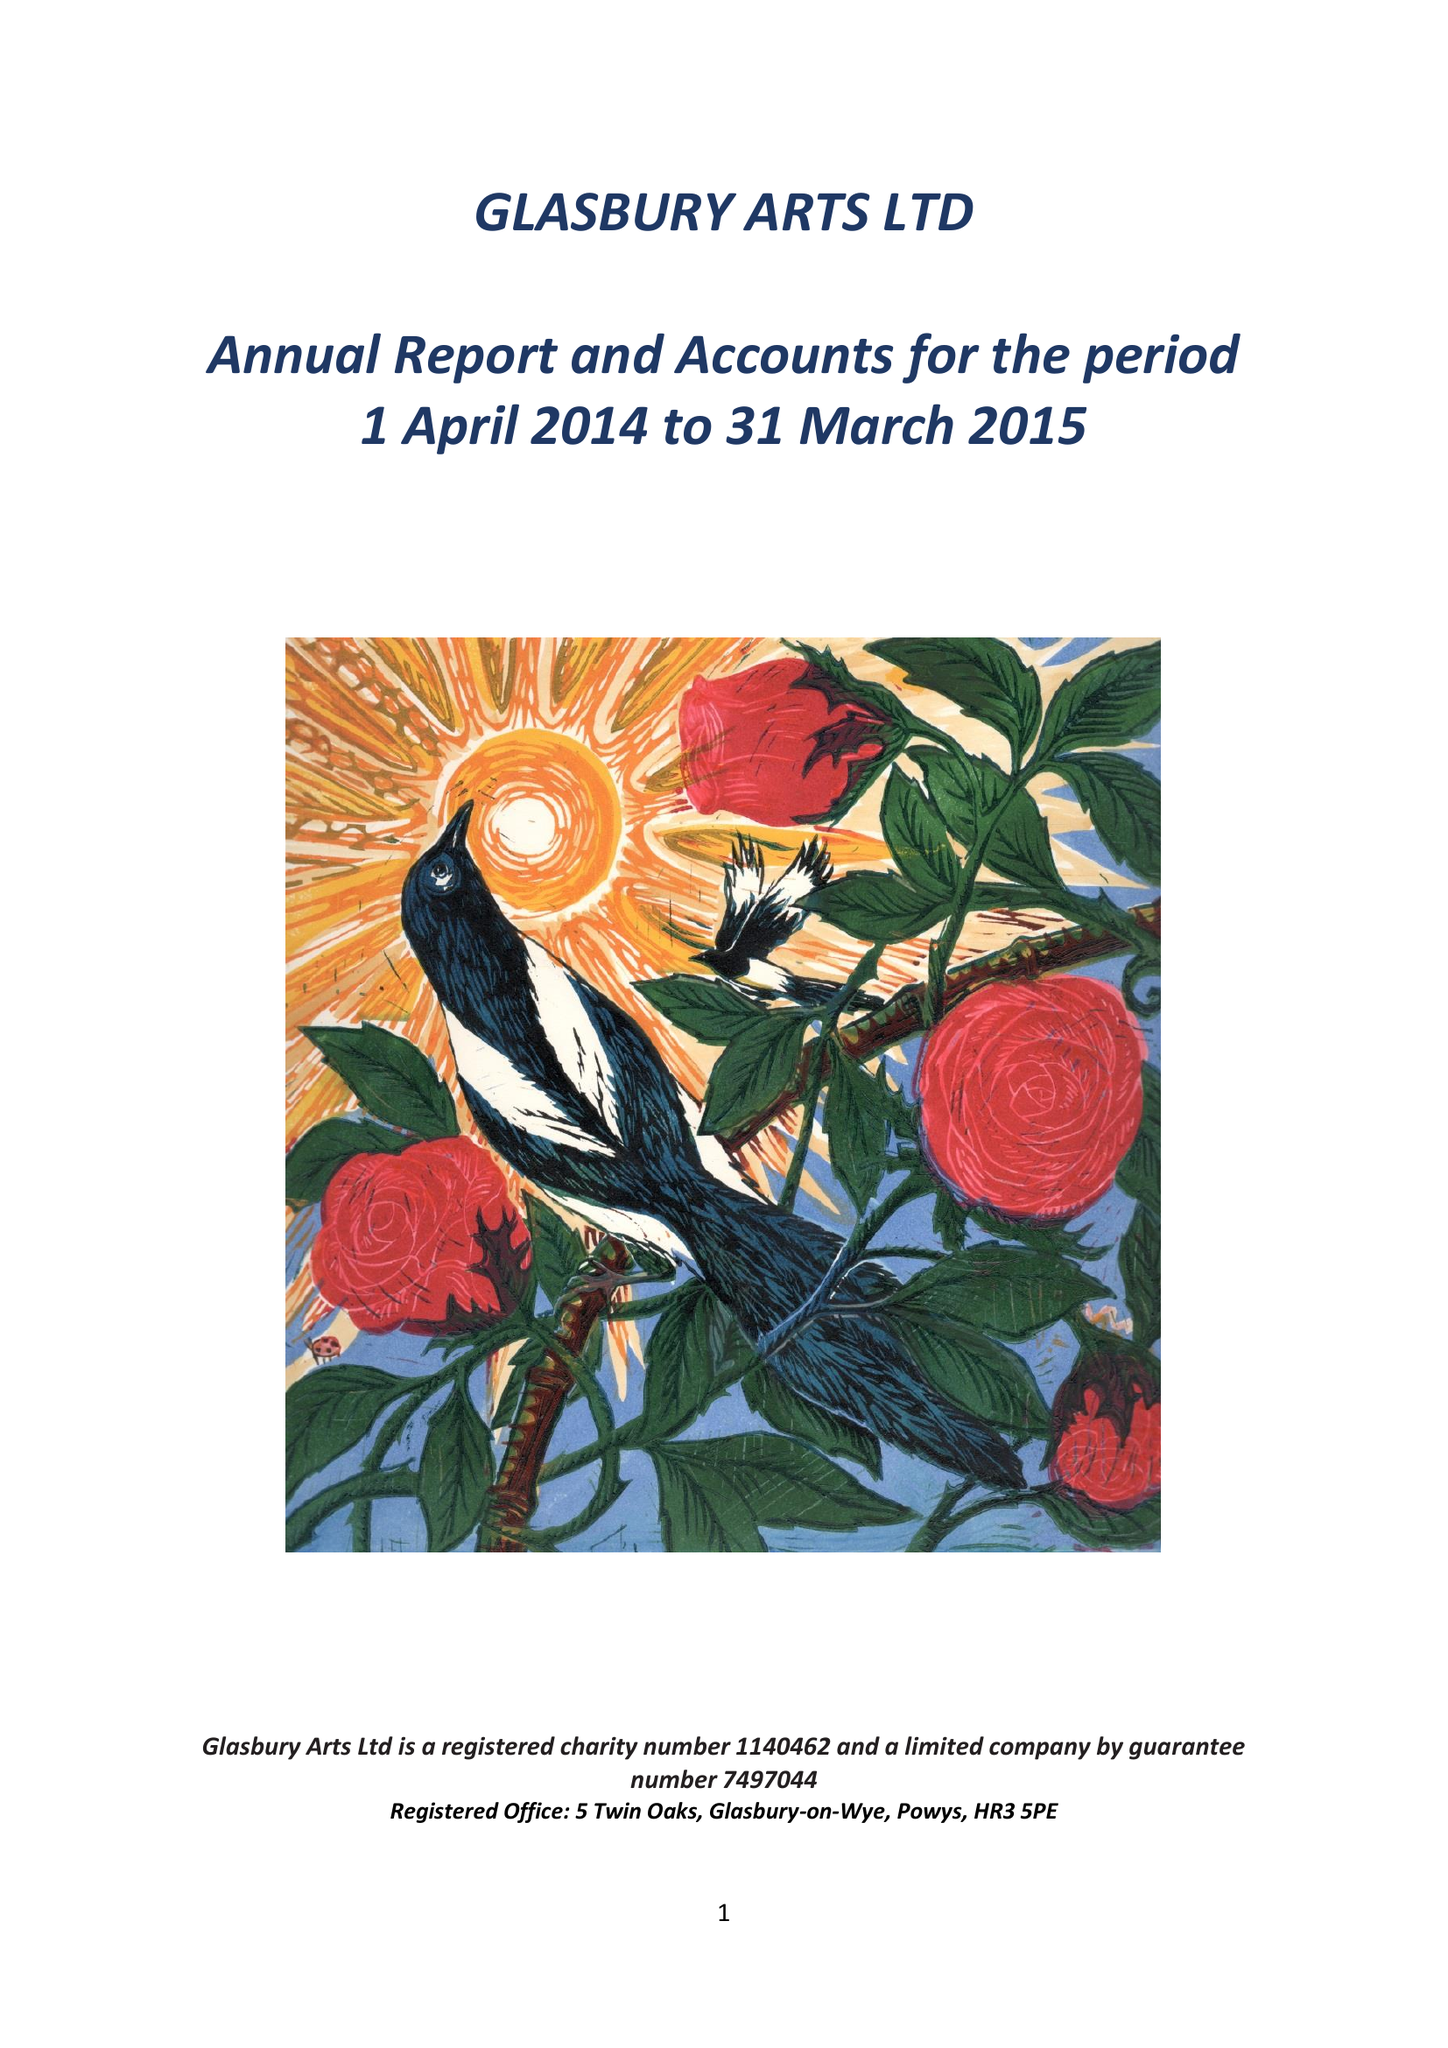What is the value for the spending_annually_in_british_pounds?
Answer the question using a single word or phrase. 25291.00 